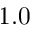Convert formula to latex. <formula><loc_0><loc_0><loc_500><loc_500>1 . 0</formula> 